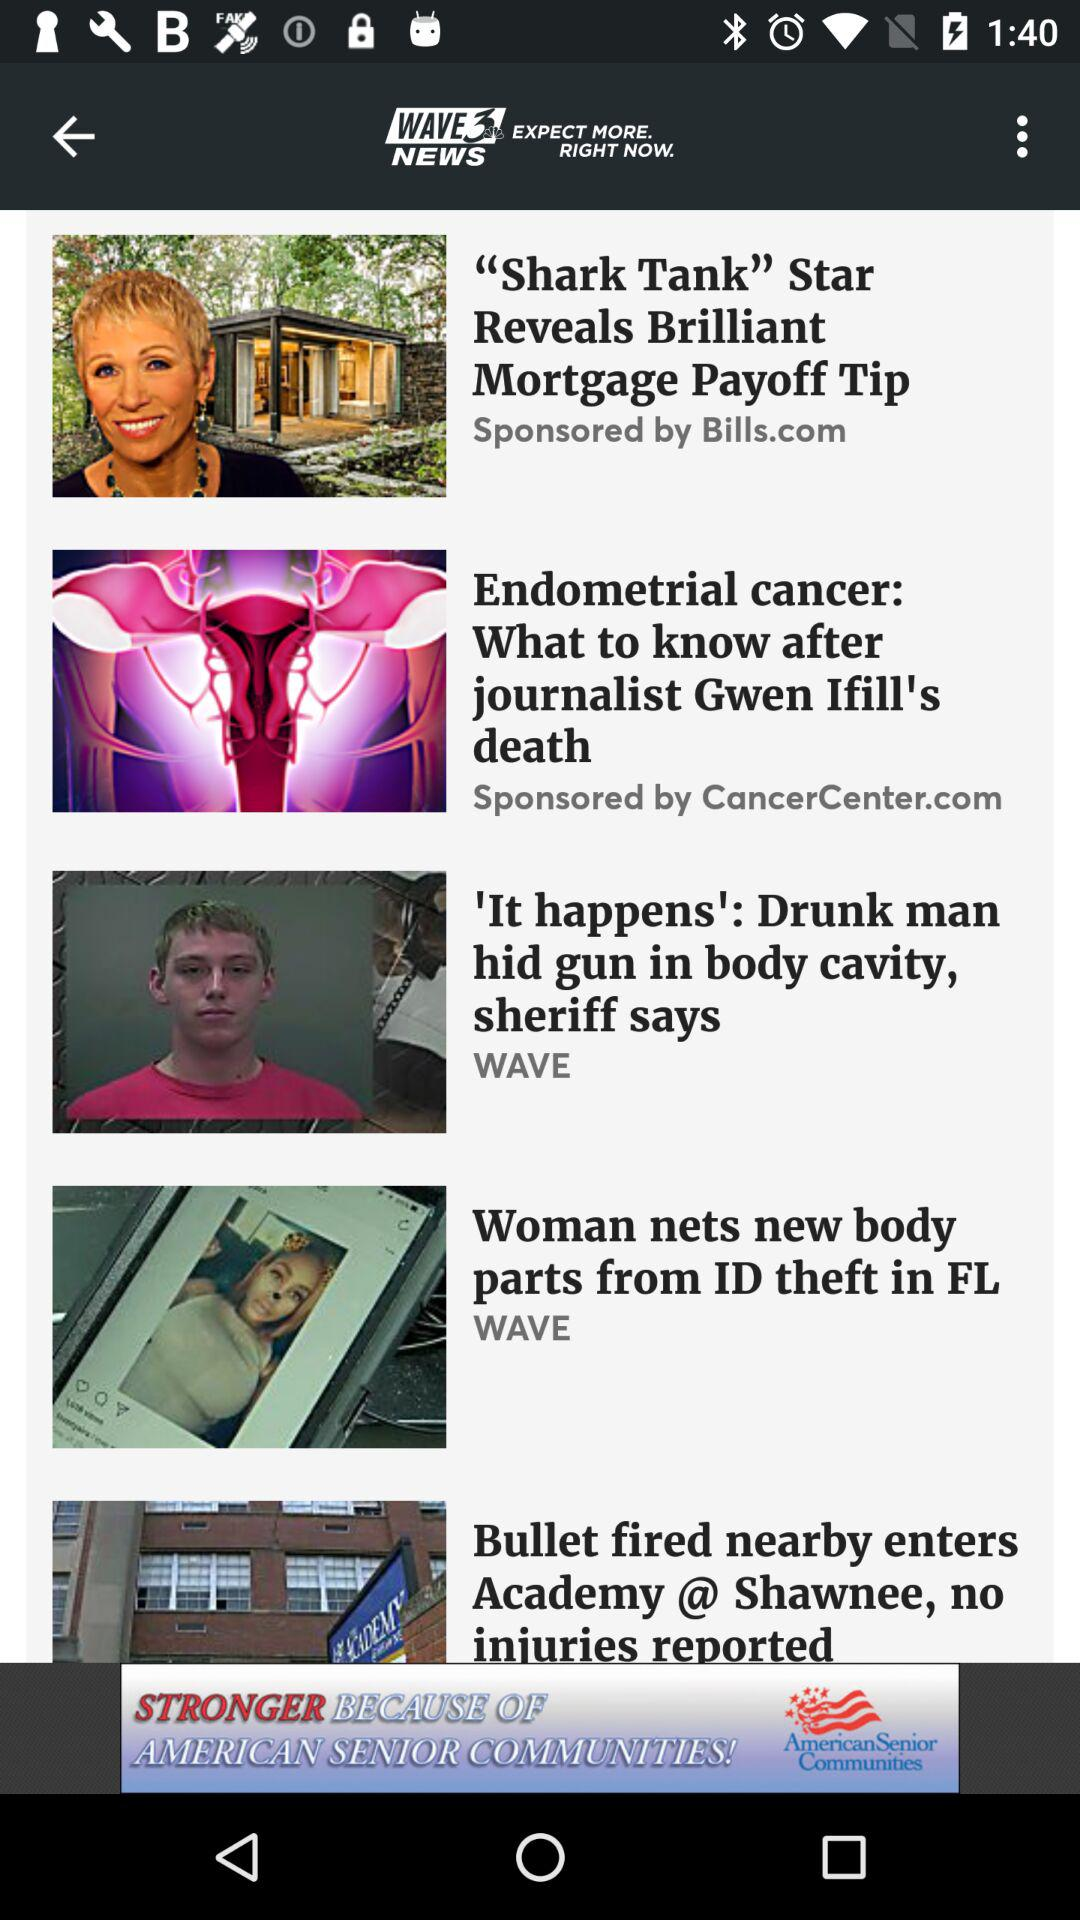Who is the author of "Bullet fired nearby enters Academy @ Shawnee, no injuries reported"?
When the provided information is insufficient, respond with <no answer>. <no answer> 